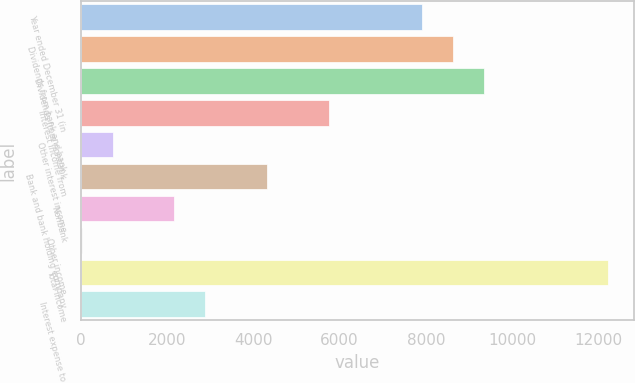Convert chart. <chart><loc_0><loc_0><loc_500><loc_500><bar_chart><fcel>Year ended December 31 (in<fcel>Dividends from bank and bank<fcel>Dividends from nonbank<fcel>Interest income from<fcel>Other interest income<fcel>Bank and bank holding company<fcel>Nonbank<fcel>Other income<fcel>Total income<fcel>Interest expense to<nl><fcel>7907.6<fcel>8624.2<fcel>9340.8<fcel>5757.8<fcel>741.6<fcel>4324.6<fcel>2174.8<fcel>25<fcel>12207.2<fcel>2891.4<nl></chart> 